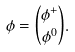Convert formula to latex. <formula><loc_0><loc_0><loc_500><loc_500>\phi = \binom { \phi ^ { + } } { \phi ^ { 0 } } .</formula> 